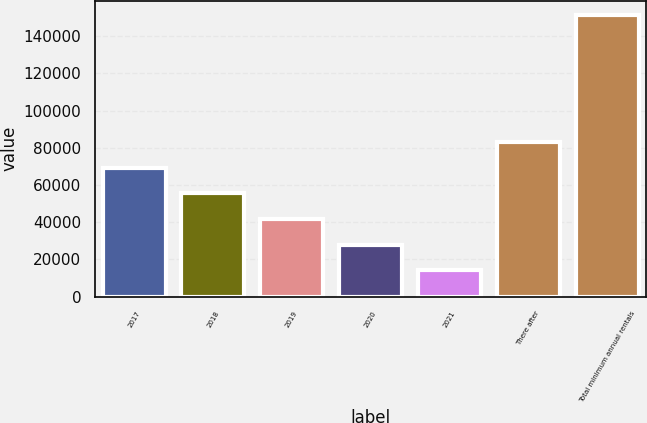Convert chart. <chart><loc_0><loc_0><loc_500><loc_500><bar_chart><fcel>2017<fcel>2018<fcel>2019<fcel>2020<fcel>2021<fcel>There after<fcel>Total minimum annual rentals<nl><fcel>69206.8<fcel>55476.1<fcel>41745.4<fcel>28014.7<fcel>14284<fcel>82937.5<fcel>151591<nl></chart> 